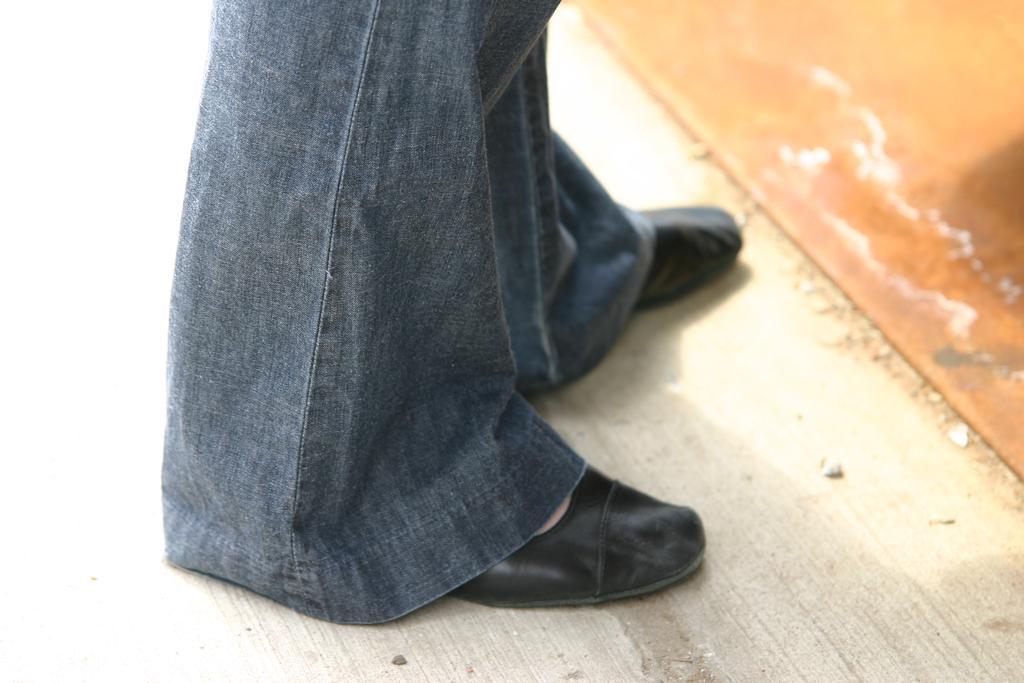How would you summarize this image in a sentence or two? In this image we can see the legs of a person and the person is wearing footwear. At the bottom we can see a wooden surface. 